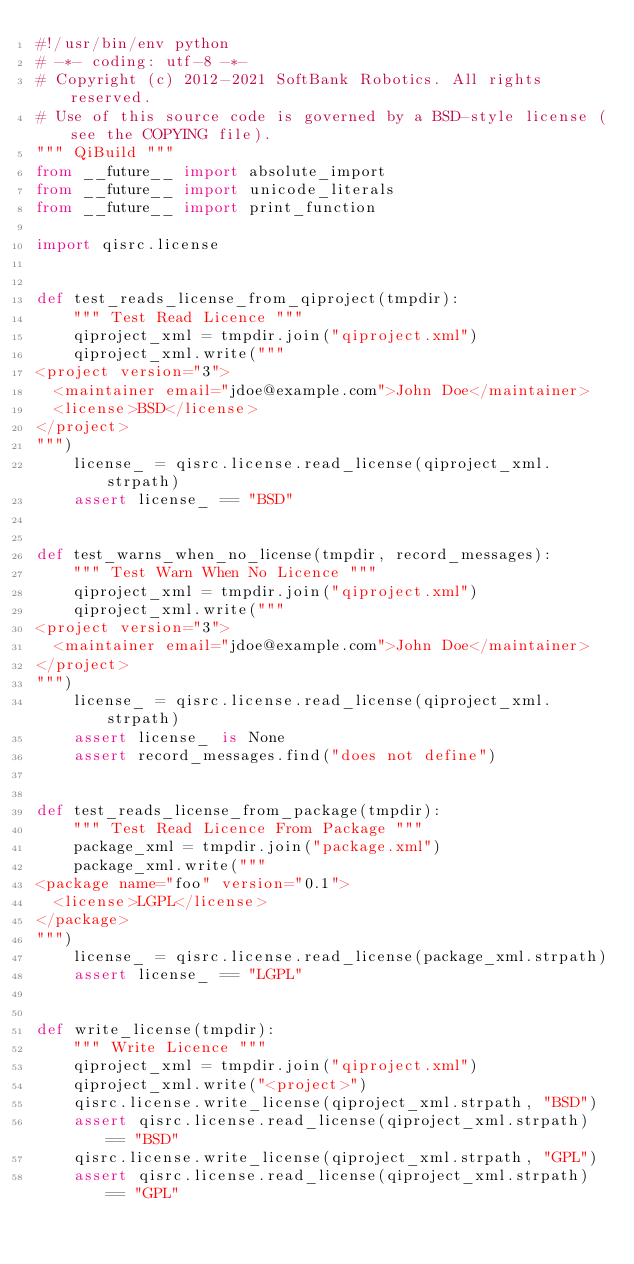<code> <loc_0><loc_0><loc_500><loc_500><_Python_>#!/usr/bin/env python
# -*- coding: utf-8 -*-
# Copyright (c) 2012-2021 SoftBank Robotics. All rights reserved.
# Use of this source code is governed by a BSD-style license (see the COPYING file).
""" QiBuild """
from __future__ import absolute_import
from __future__ import unicode_literals
from __future__ import print_function

import qisrc.license


def test_reads_license_from_qiproject(tmpdir):
    """ Test Read Licence """
    qiproject_xml = tmpdir.join("qiproject.xml")
    qiproject_xml.write("""
<project version="3">
  <maintainer email="jdoe@example.com">John Doe</maintainer>
  <license>BSD</license>
</project>
""")
    license_ = qisrc.license.read_license(qiproject_xml.strpath)
    assert license_ == "BSD"


def test_warns_when_no_license(tmpdir, record_messages):
    """ Test Warn When No Licence """
    qiproject_xml = tmpdir.join("qiproject.xml")
    qiproject_xml.write("""
<project version="3">
  <maintainer email="jdoe@example.com">John Doe</maintainer>
</project>
""")
    license_ = qisrc.license.read_license(qiproject_xml.strpath)
    assert license_ is None
    assert record_messages.find("does not define")


def test_reads_license_from_package(tmpdir):
    """ Test Read Licence From Package """
    package_xml = tmpdir.join("package.xml")
    package_xml.write("""
<package name="foo" version="0.1">
  <license>LGPL</license>
</package>
""")
    license_ = qisrc.license.read_license(package_xml.strpath)
    assert license_ == "LGPL"


def write_license(tmpdir):
    """ Write Licence """
    qiproject_xml = tmpdir.join("qiproject.xml")
    qiproject_xml.write("<project>")
    qisrc.license.write_license(qiproject_xml.strpath, "BSD")
    assert qisrc.license.read_license(qiproject_xml.strpath) == "BSD"
    qisrc.license.write_license(qiproject_xml.strpath, "GPL")
    assert qisrc.license.read_license(qiproject_xml.strpath) == "GPL"
</code> 